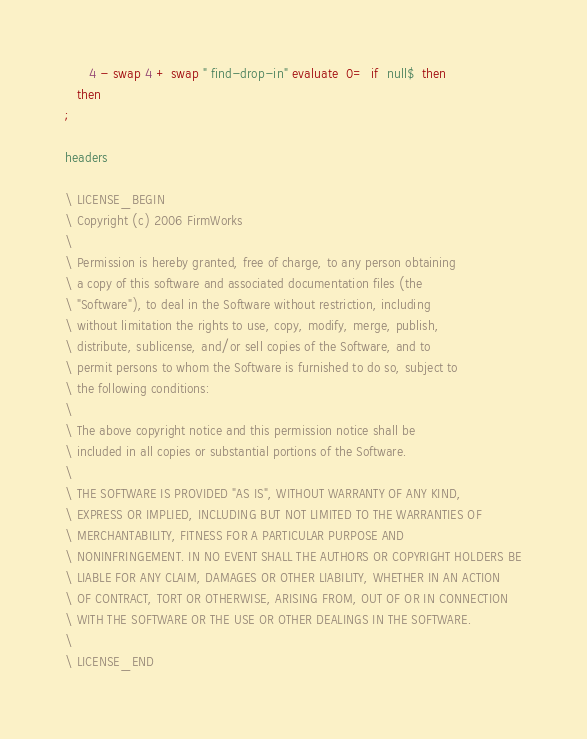<code> <loc_0><loc_0><loc_500><loc_500><_Forth_>      4 - swap 4 + swap " find-drop-in" evaluate  0=  if  null$  then
   then
;

headers

\ LICENSE_BEGIN
\ Copyright (c) 2006 FirmWorks
\ 
\ Permission is hereby granted, free of charge, to any person obtaining
\ a copy of this software and associated documentation files (the
\ "Software"), to deal in the Software without restriction, including
\ without limitation the rights to use, copy, modify, merge, publish,
\ distribute, sublicense, and/or sell copies of the Software, and to
\ permit persons to whom the Software is furnished to do so, subject to
\ the following conditions:
\ 
\ The above copyright notice and this permission notice shall be
\ included in all copies or substantial portions of the Software.
\ 
\ THE SOFTWARE IS PROVIDED "AS IS", WITHOUT WARRANTY OF ANY KIND,
\ EXPRESS OR IMPLIED, INCLUDING BUT NOT LIMITED TO THE WARRANTIES OF
\ MERCHANTABILITY, FITNESS FOR A PARTICULAR PURPOSE AND
\ NONINFRINGEMENT. IN NO EVENT SHALL THE AUTHORS OR COPYRIGHT HOLDERS BE
\ LIABLE FOR ANY CLAIM, DAMAGES OR OTHER LIABILITY, WHETHER IN AN ACTION
\ OF CONTRACT, TORT OR OTHERWISE, ARISING FROM, OUT OF OR IN CONNECTION
\ WITH THE SOFTWARE OR THE USE OR OTHER DEALINGS IN THE SOFTWARE.
\
\ LICENSE_END
</code> 